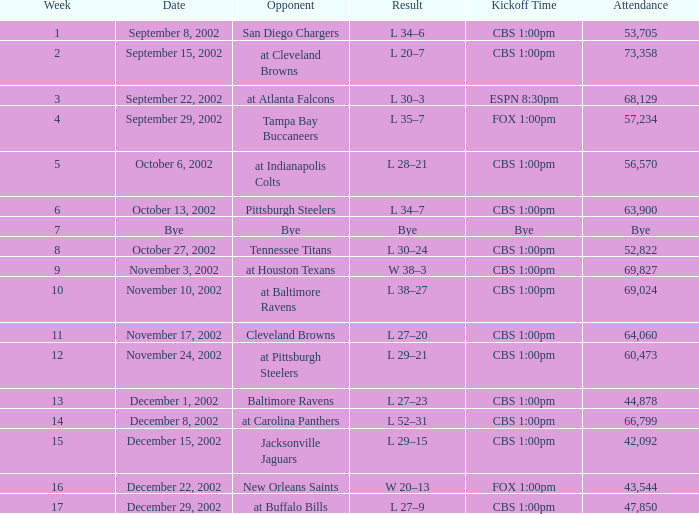What is the commencement time on november 10, 2002? CBS 1:00pm. 